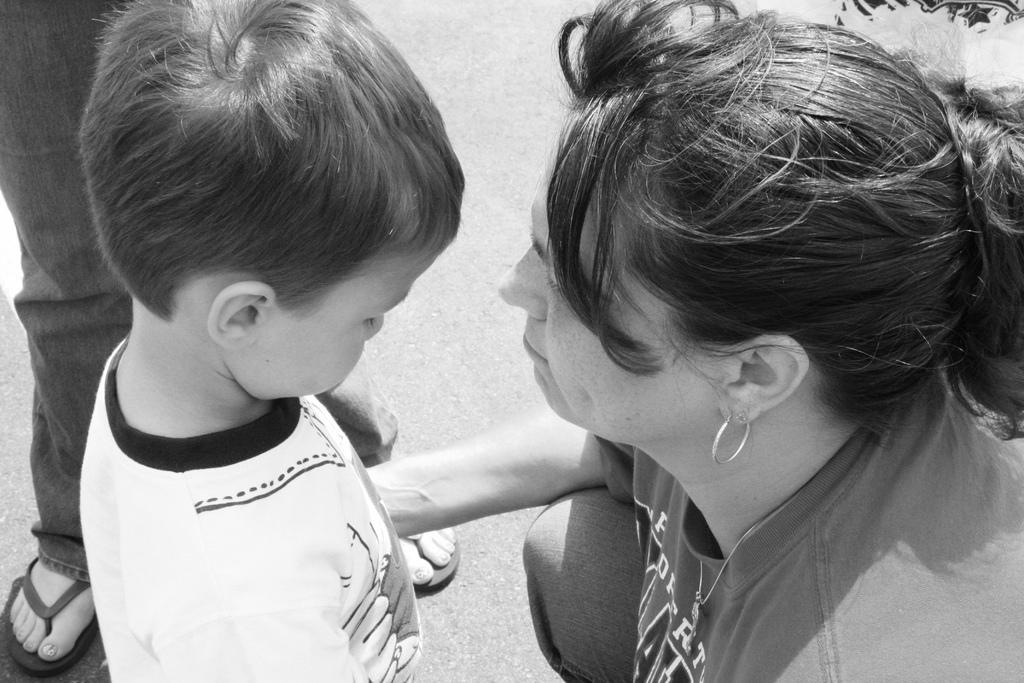What is the color scheme of the image? The image is black and white. Who are the people in the image? There is a boy and a woman in the image. Can you describe the position of a person in the image? A person is standing on the road, and their legs are visible on the left side of the image. What type of patch is sewn onto the boy's shirt in the image? There is no patch visible on the boy's shirt in the image. What is the zinc content of the road in the image? The image does not provide information about the zinc content of the road. 